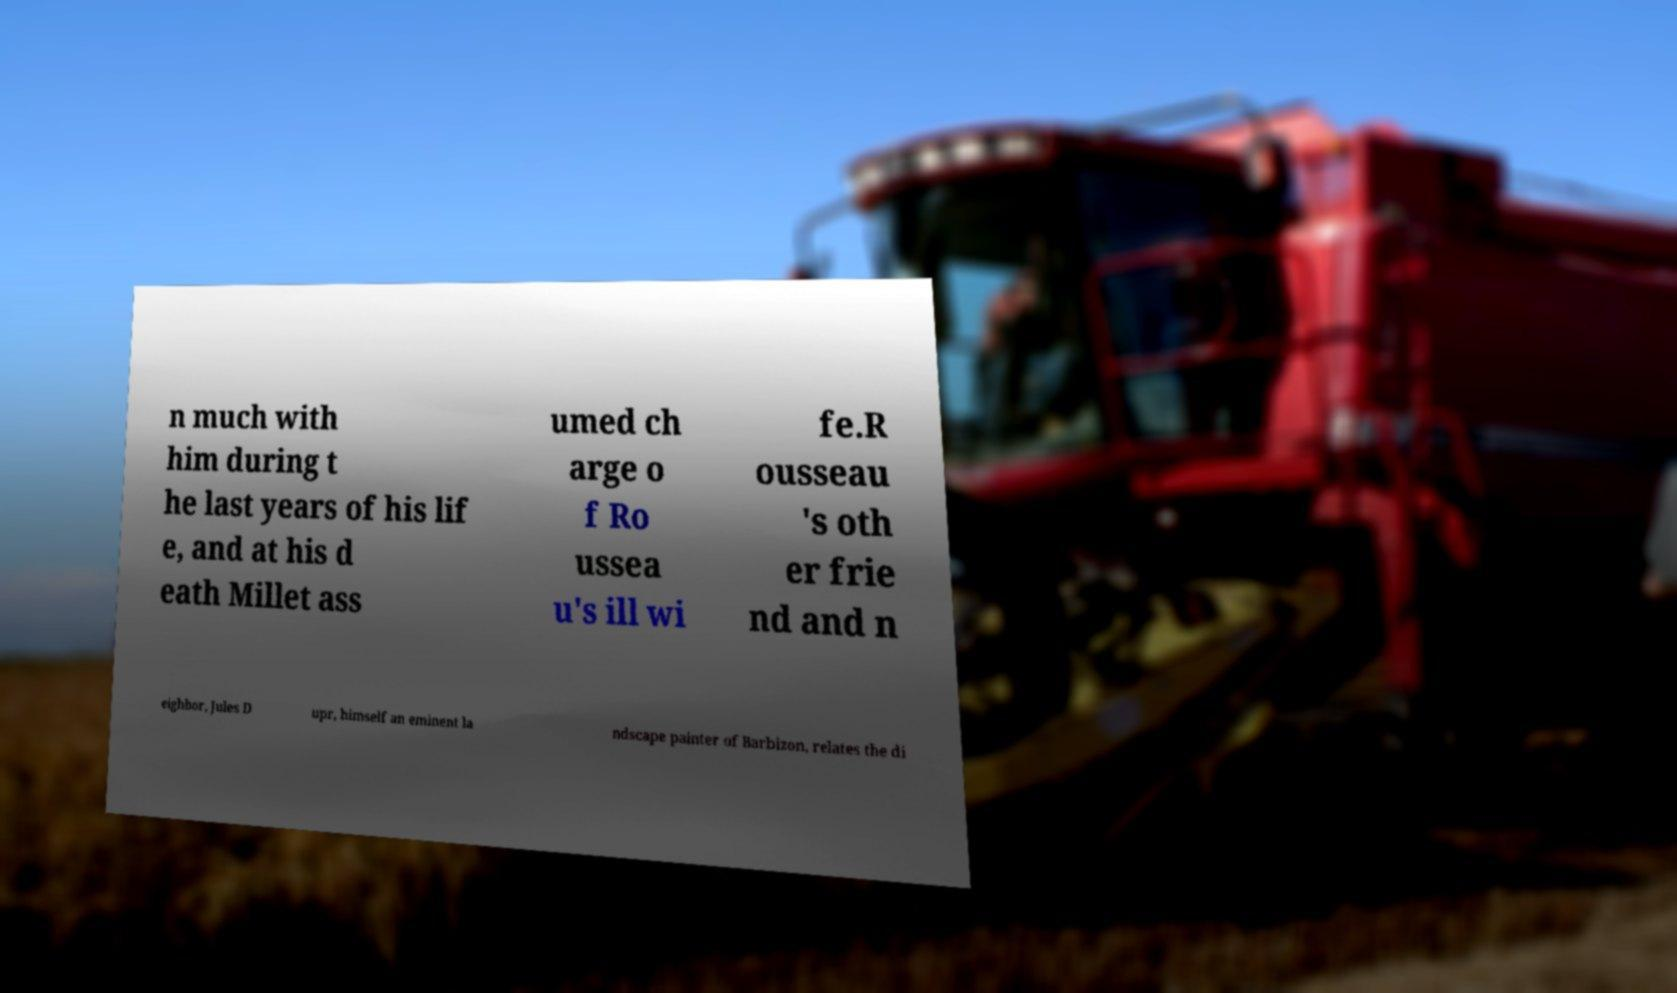Can you accurately transcribe the text from the provided image for me? n much with him during t he last years of his lif e, and at his d eath Millet ass umed ch arge o f Ro ussea u's ill wi fe.R ousseau 's oth er frie nd and n eighbor, Jules D upr, himself an eminent la ndscape painter of Barbizon, relates the di 